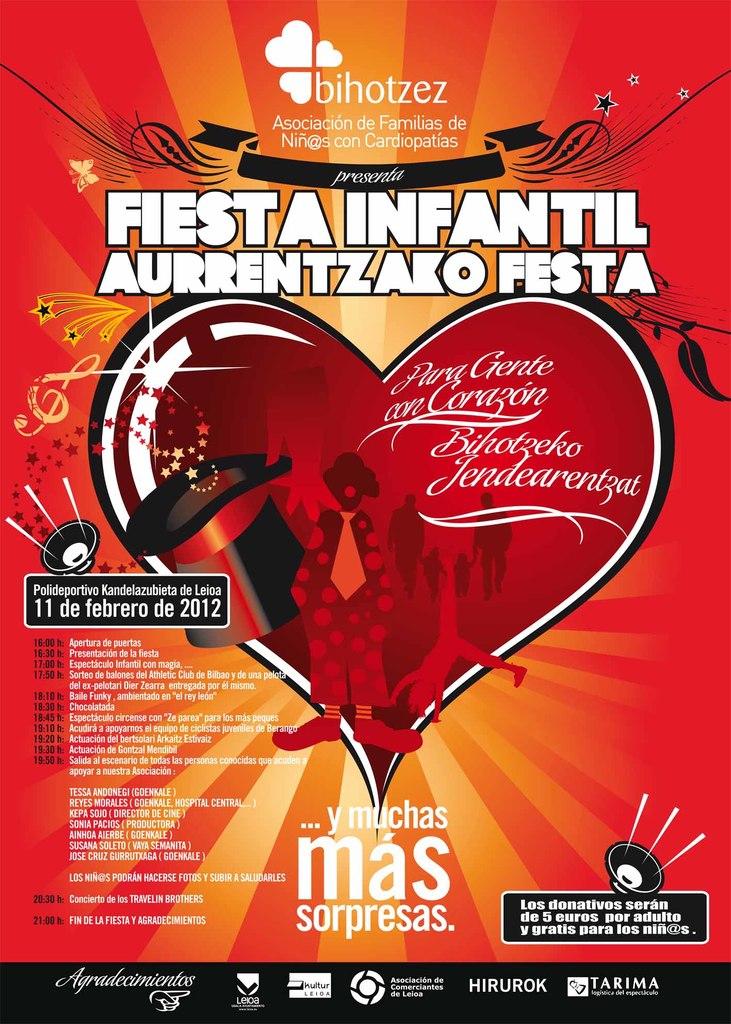What language is this in?
Your response must be concise. Spanish. 